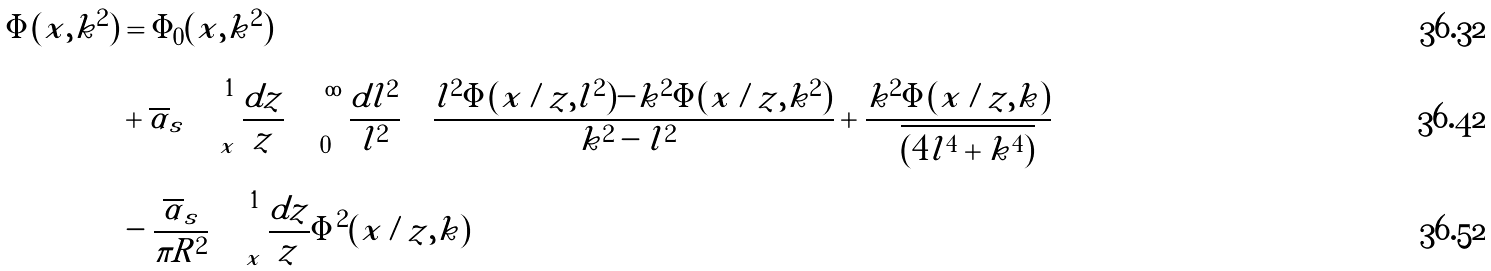<formula> <loc_0><loc_0><loc_500><loc_500>\Phi ( x , k ^ { 2 } ) & = \Phi _ { 0 } ( x , k ^ { 2 } ) \\ & + \overline { \alpha } _ { s } \int _ { x } ^ { 1 } \frac { d z } { z } \int _ { 0 } ^ { \infty } \frac { d l ^ { 2 } } { l ^ { 2 } } \left [ \frac { l ^ { 2 } \Phi ( x / z , l ^ { 2 } ) - k ^ { 2 } \Phi ( x / z , k ^ { 2 } ) } { | k ^ { 2 } - l ^ { 2 } | } + \frac { k ^ { 2 } \Phi ( x / z , k ) } { \sqrt { ( 4 l ^ { 4 } + k ^ { 4 } ) } } \right ] \\ & - \frac { \overline { \alpha } _ { s } } { \pi R ^ { 2 } } \int _ { x } ^ { 1 } \frac { d z } { z } \Phi ^ { 2 } ( x / z , k )</formula> 